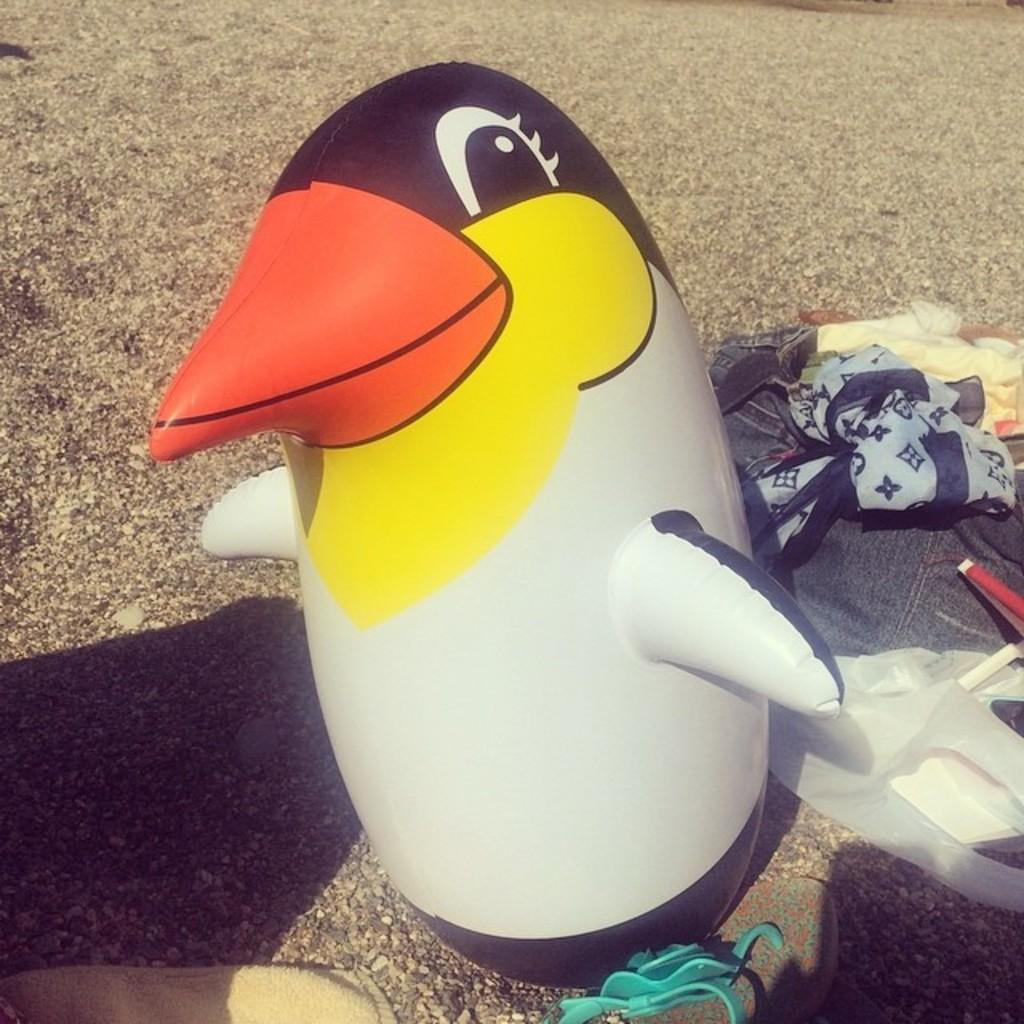What is the main object on the ground in the image? There is an inflatable tube on the ground. What else can be seen on the ground besides the inflatable tube? There are clothes and a polyethylene cover on the ground. Are there any other objects visible on the ground? Yes, there are other objects visible on the ground. How does the flame affect the inflatable tube in the image? There is no flame present in the image, so it cannot affect the inflatable tube. 